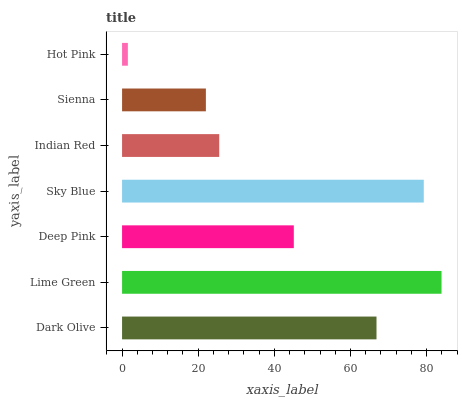Is Hot Pink the minimum?
Answer yes or no. Yes. Is Lime Green the maximum?
Answer yes or no. Yes. Is Deep Pink the minimum?
Answer yes or no. No. Is Deep Pink the maximum?
Answer yes or no. No. Is Lime Green greater than Deep Pink?
Answer yes or no. Yes. Is Deep Pink less than Lime Green?
Answer yes or no. Yes. Is Deep Pink greater than Lime Green?
Answer yes or no. No. Is Lime Green less than Deep Pink?
Answer yes or no. No. Is Deep Pink the high median?
Answer yes or no. Yes. Is Deep Pink the low median?
Answer yes or no. Yes. Is Dark Olive the high median?
Answer yes or no. No. Is Sky Blue the low median?
Answer yes or no. No. 